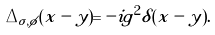<formula> <loc_0><loc_0><loc_500><loc_500>\Delta _ { \sigma , \phi } ( x - y ) = - i g ^ { 2 } \delta ( x - y ) .</formula> 